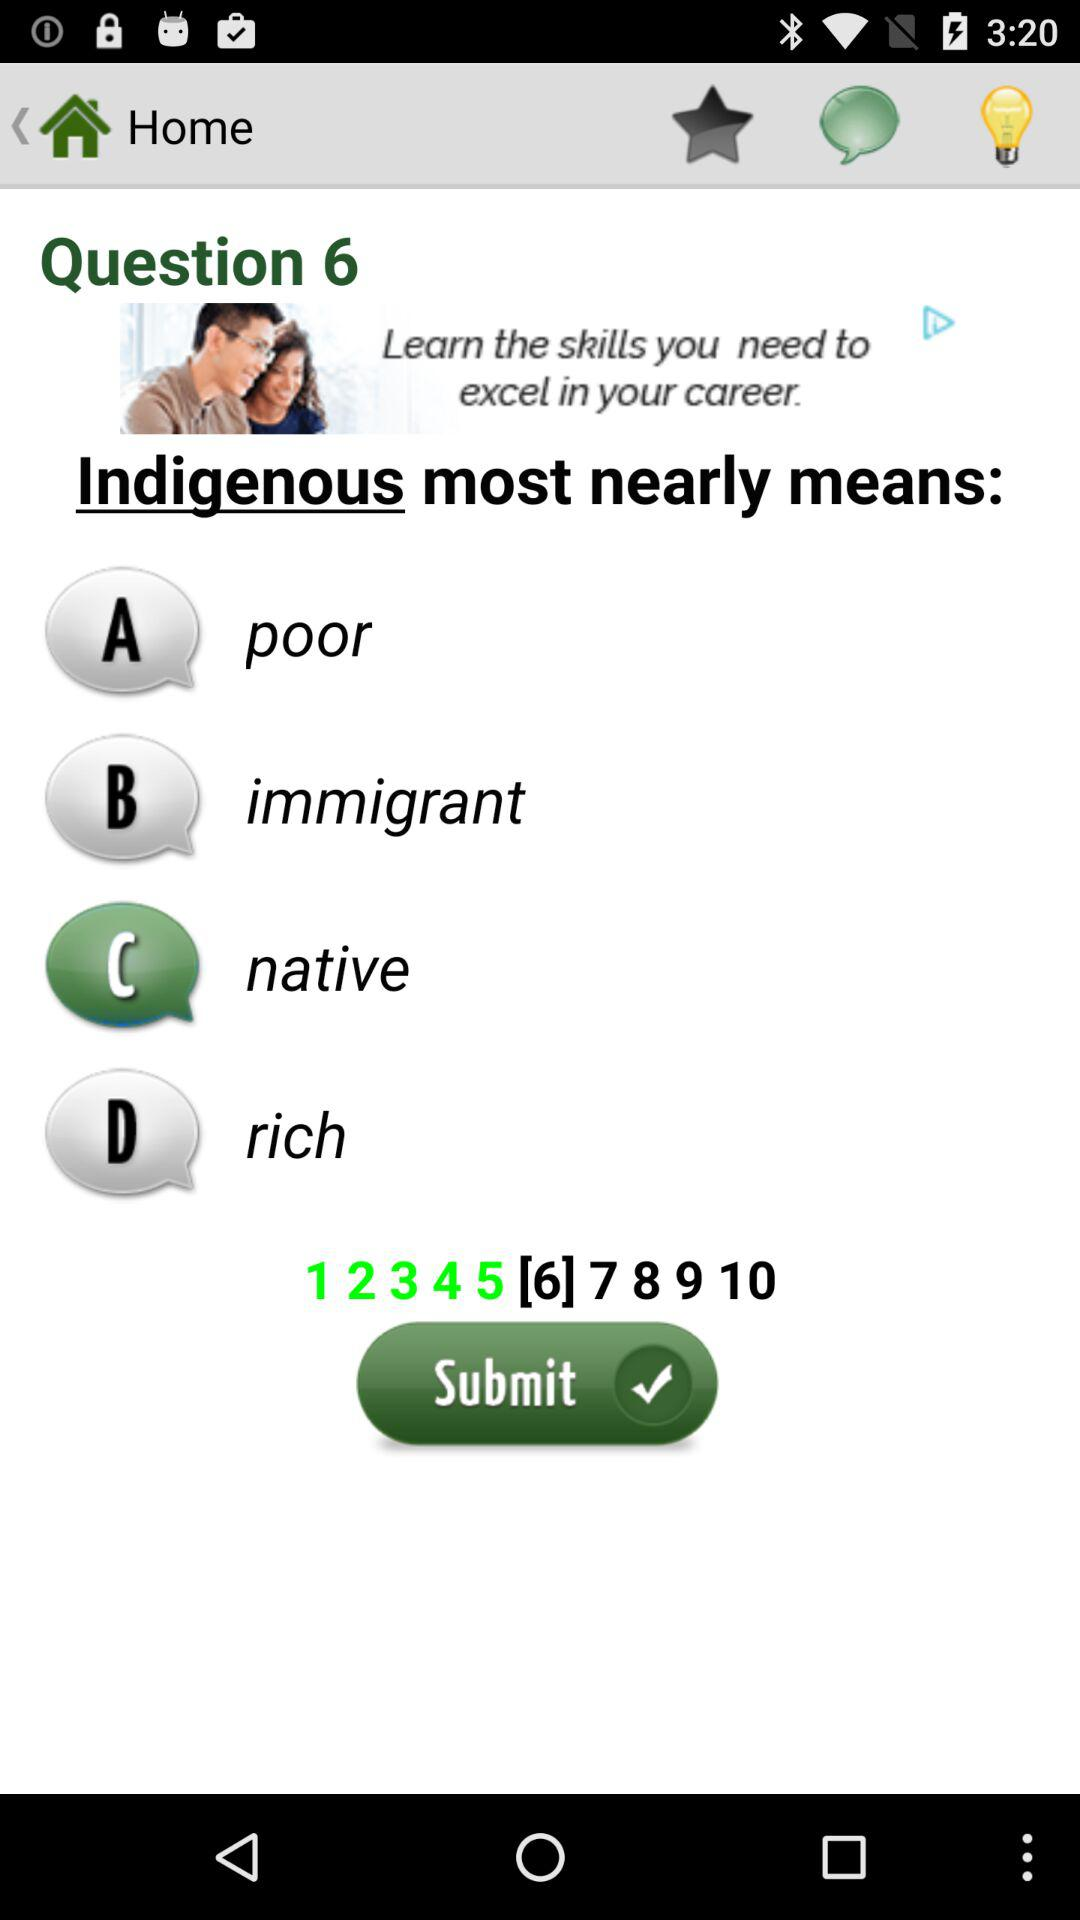How many options are there in total?
Answer the question using a single word or phrase. 4 